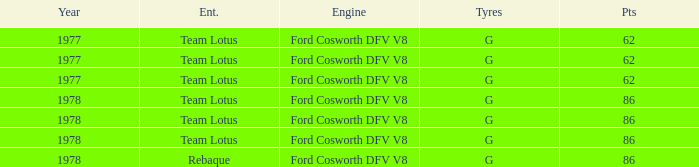What is the Focus that has a Year bigger than 1977? 86, 86, 86, 86. Give me the full table as a dictionary. {'header': ['Year', 'Ent.', 'Engine', 'Tyres', 'Pts'], 'rows': [['1977', 'Team Lotus', 'Ford Cosworth DFV V8', 'G', '62'], ['1977', 'Team Lotus', 'Ford Cosworth DFV V8', 'G', '62'], ['1977', 'Team Lotus', 'Ford Cosworth DFV V8', 'G', '62'], ['1978', 'Team Lotus', 'Ford Cosworth DFV V8', 'G', '86'], ['1978', 'Team Lotus', 'Ford Cosworth DFV V8', 'G', '86'], ['1978', 'Team Lotus', 'Ford Cosworth DFV V8', 'G', '86'], ['1978', 'Rebaque', 'Ford Cosworth DFV V8', 'G', '86']]} 